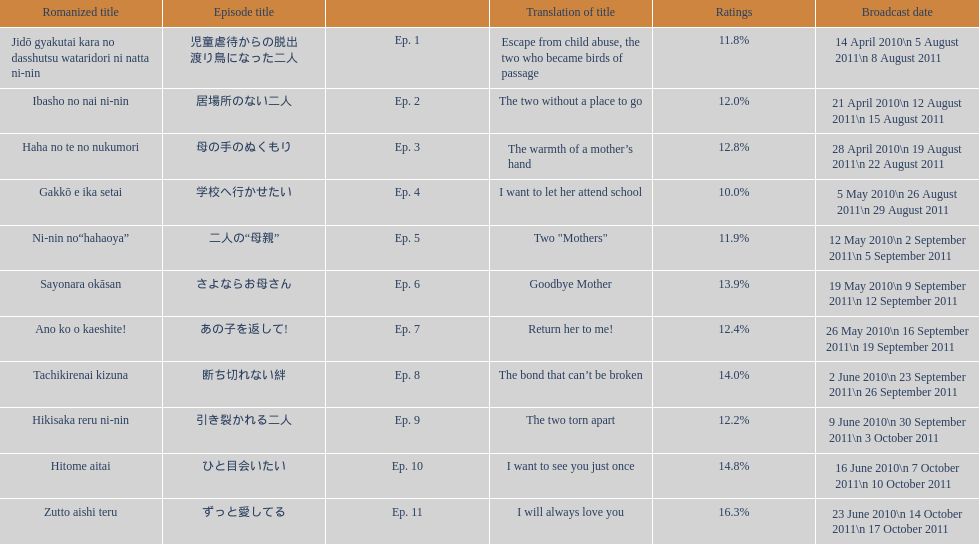Which episode was titled i want to let her attend school? Ep. 4. 